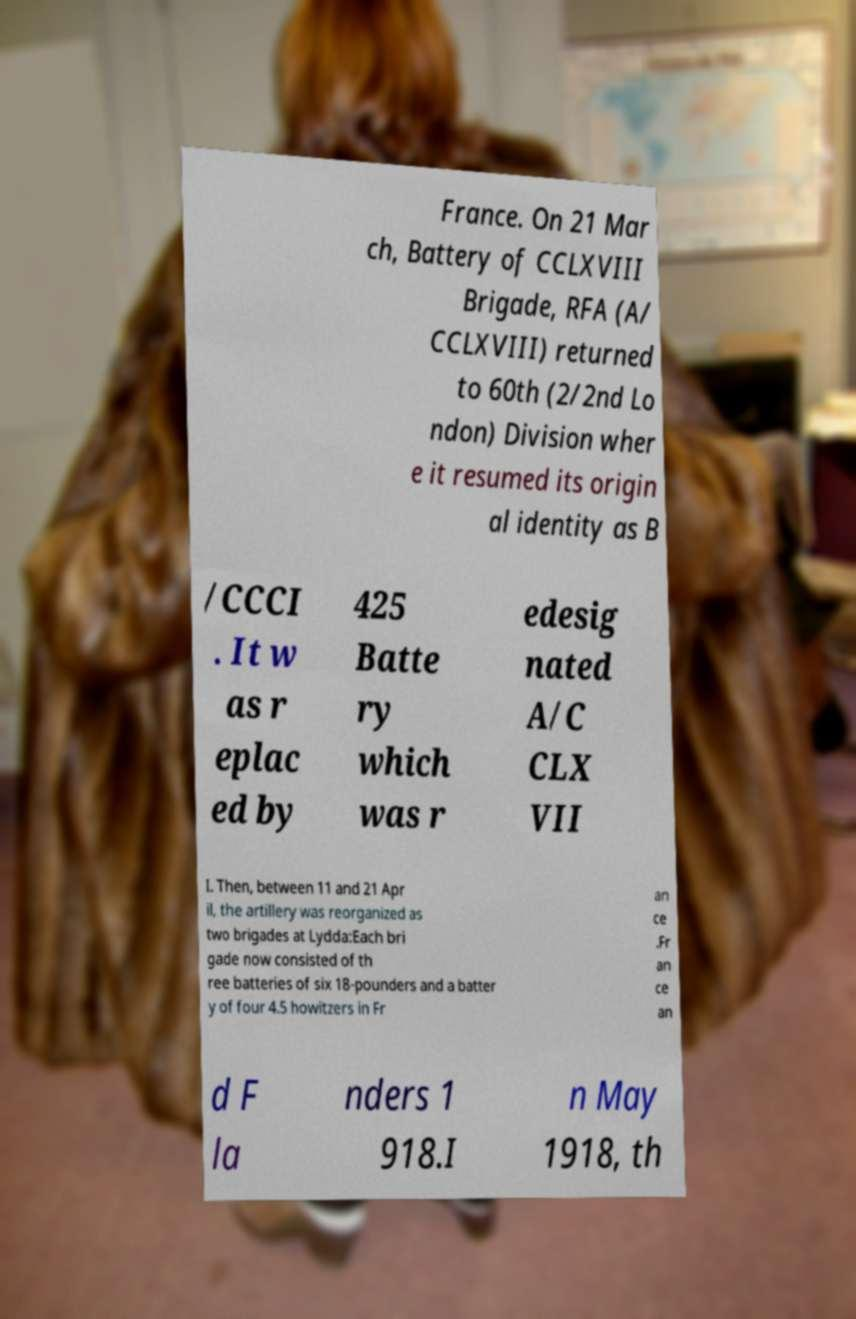Could you extract and type out the text from this image? France. On 21 Mar ch, Battery of CCLXVIII Brigade, RFA (A/ CCLXVIII) returned to 60th (2/2nd Lo ndon) Division wher e it resumed its origin al identity as B /CCCI . It w as r eplac ed by 425 Batte ry which was r edesig nated A/C CLX VII I. Then, between 11 and 21 Apr il, the artillery was reorganized as two brigades at Lydda:Each bri gade now consisted of th ree batteries of six 18-pounders and a batter y of four 4.5 howitzers in Fr an ce .Fr an ce an d F la nders 1 918.I n May 1918, th 